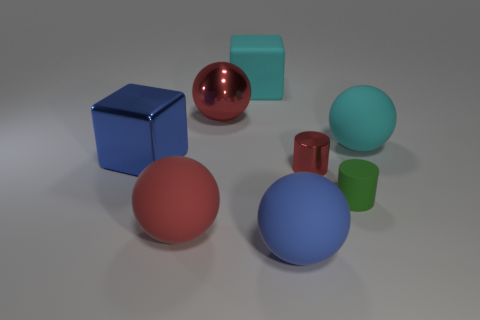Can you describe the texture and material of the red object in the center? The red object in the center has a smooth surface with a reflective material, giving it a shiny appearance that indicates it might be made of a glossy plastic or polished metal. 